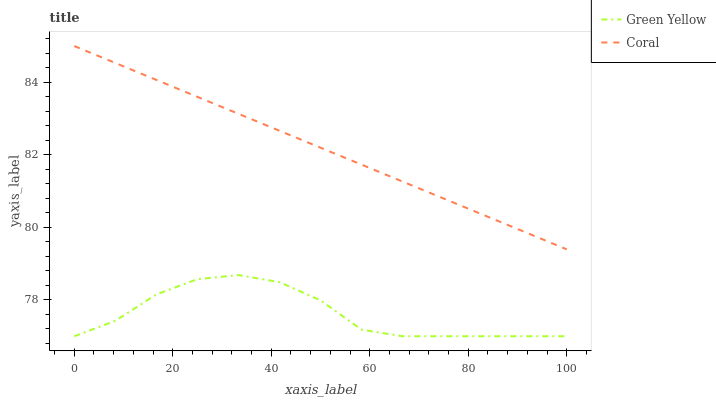Does Green Yellow have the minimum area under the curve?
Answer yes or no. Yes. Does Coral have the maximum area under the curve?
Answer yes or no. Yes. Does Green Yellow have the maximum area under the curve?
Answer yes or no. No. Is Coral the smoothest?
Answer yes or no. Yes. Is Green Yellow the roughest?
Answer yes or no. Yes. Is Green Yellow the smoothest?
Answer yes or no. No. Does Green Yellow have the lowest value?
Answer yes or no. Yes. Does Coral have the highest value?
Answer yes or no. Yes. Does Green Yellow have the highest value?
Answer yes or no. No. Is Green Yellow less than Coral?
Answer yes or no. Yes. Is Coral greater than Green Yellow?
Answer yes or no. Yes. Does Green Yellow intersect Coral?
Answer yes or no. No. 